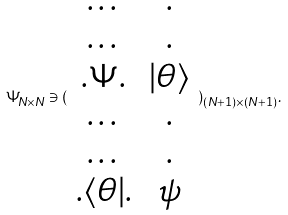<formula> <loc_0><loc_0><loc_500><loc_500>\Psi _ { N \times N } \ni ( \begin{array} { c c } \dots & . \\ \dots & . \\ . \Psi . & | \theta \rangle \\ \dots & . \\ \dots & . \\ . \langle \theta | . & \psi \end{array} ) _ { ( N + 1 ) \times ( N + 1 ) } .</formula> 